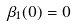<formula> <loc_0><loc_0><loc_500><loc_500>\beta _ { 1 } ( 0 ) = 0</formula> 